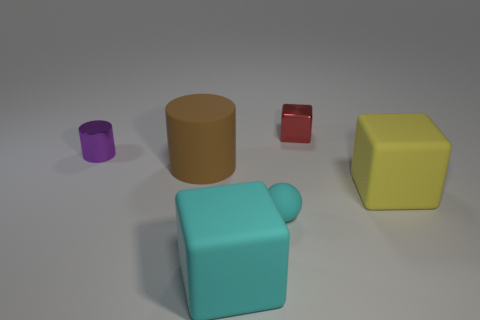Add 1 big cyan rubber cubes. How many objects exist? 7 Subtract all cylinders. How many objects are left? 4 Subtract all tiny blue shiny cylinders. Subtract all tiny red shiny blocks. How many objects are left? 5 Add 6 tiny cylinders. How many tiny cylinders are left? 7 Add 3 tiny red objects. How many tiny red objects exist? 4 Subtract 0 gray cylinders. How many objects are left? 6 